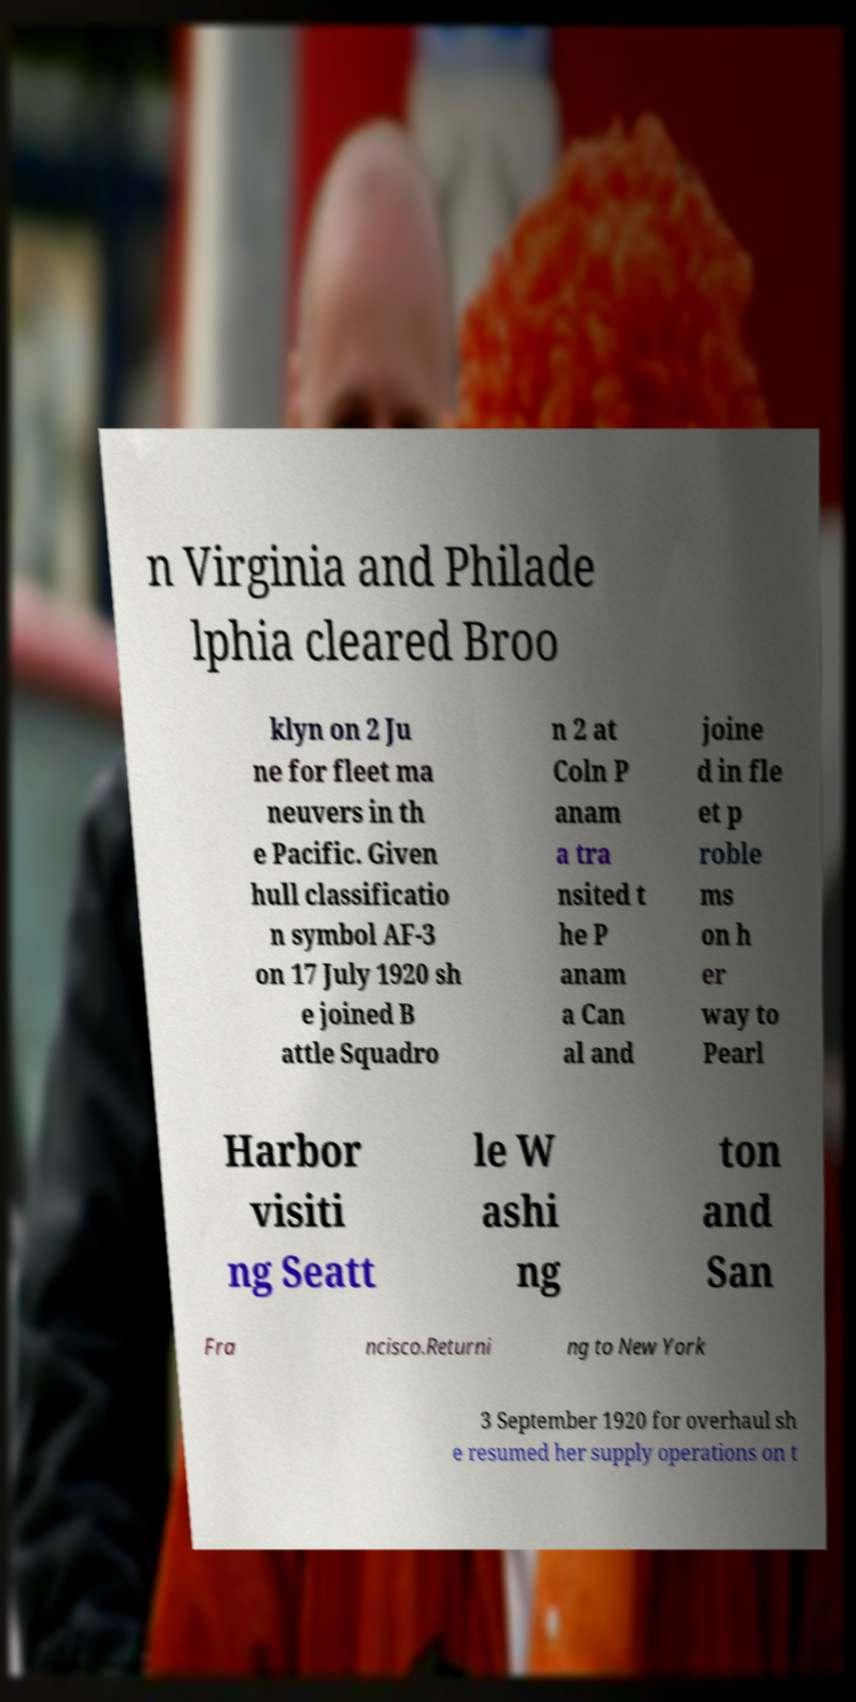I need the written content from this picture converted into text. Can you do that? n Virginia and Philade lphia cleared Broo klyn on 2 Ju ne for fleet ma neuvers in th e Pacific. Given hull classificatio n symbol AF-3 on 17 July 1920 sh e joined B attle Squadro n 2 at Coln P anam a tra nsited t he P anam a Can al and joine d in fle et p roble ms on h er way to Pearl Harbor visiti ng Seatt le W ashi ng ton and San Fra ncisco.Returni ng to New York 3 September 1920 for overhaul sh e resumed her supply operations on t 